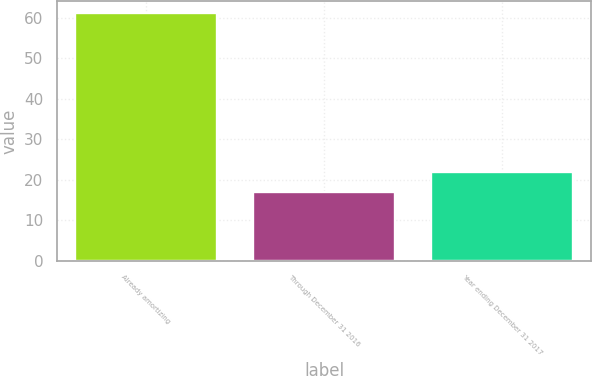<chart> <loc_0><loc_0><loc_500><loc_500><bar_chart><fcel>Already amortizing<fcel>Through December 31 2016<fcel>Year ending December 31 2017<nl><fcel>61<fcel>17<fcel>22<nl></chart> 